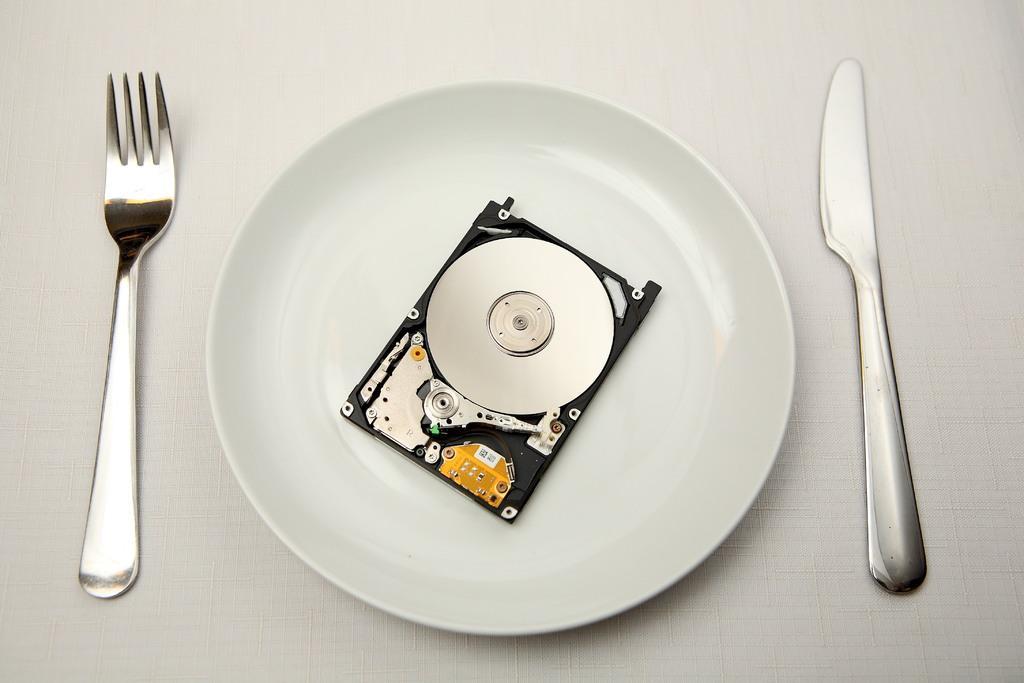Could you give a brief overview of what you see in this image? In the image there is a plate and on the plate there is some object, on the left side there is a fork and on the right side there is a knife. 